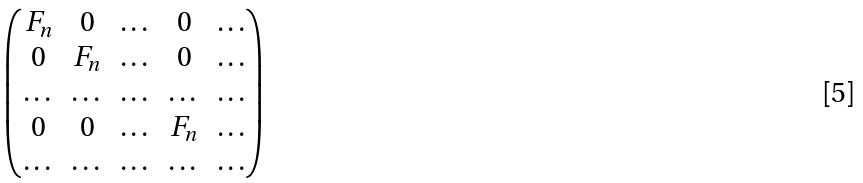<formula> <loc_0><loc_0><loc_500><loc_500>\begin{pmatrix} F _ { n } & 0 & \dots & 0 & \dots \\ 0 & F _ { n } & \dots & 0 & \dots \\ \dots & \dots & \dots & \dots & \dots \\ 0 & 0 & \dots & F _ { n } & \dots \\ \dots & \dots & \dots & \dots & \dots \end{pmatrix}</formula> 